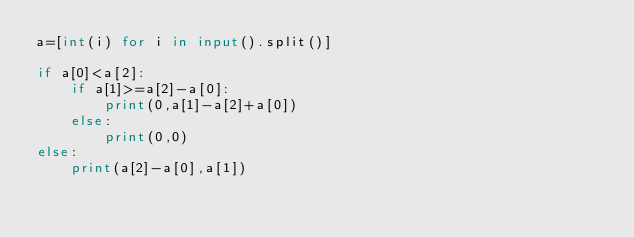<code> <loc_0><loc_0><loc_500><loc_500><_Python_>a=[int(i) for i in input().split()]

if a[0]<a[2]:
    if a[1]>=a[2]-a[0]:
        print(0,a[1]-a[2]+a[0])
    else:
        print(0,0)
else:
    print(a[2]-a[0],a[1])</code> 